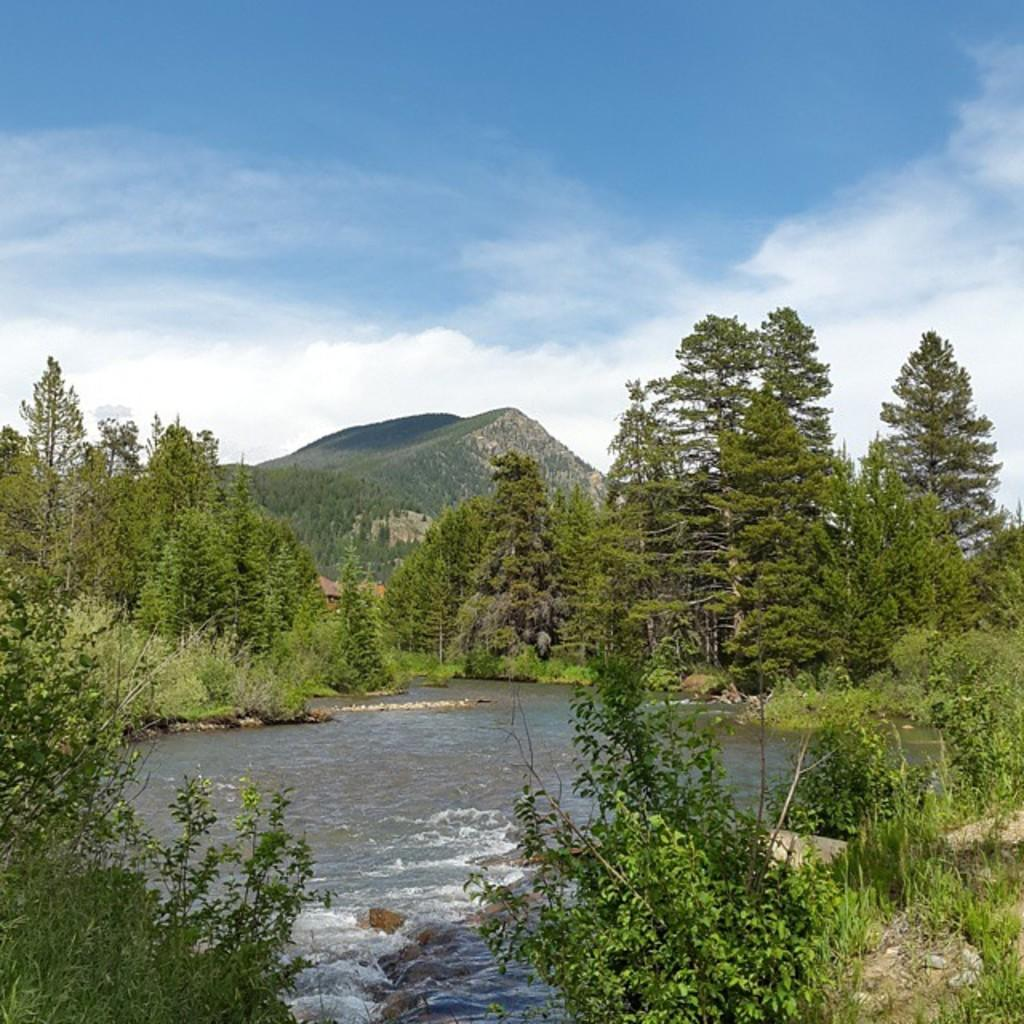What is the main feature in the center of the image? There is a river in the center of the image. What other natural elements can be seen in the image? There are plants and rocks visible in the image. What can be seen in the background of the image? There are trees and mountains in the background of the image. What is visible at the top of the image? The sky is visible at the top of the image. How many sheep are present in the image? There are no sheep present in the image. What is the mass of the rocks in the image? The mass of the rocks cannot be determined from the image alone. 